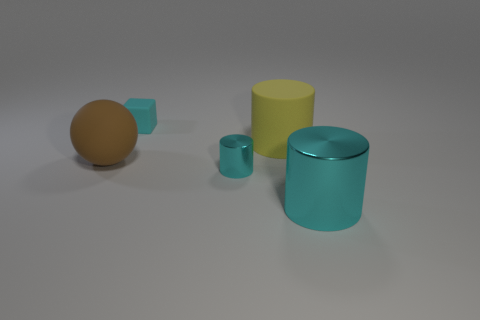Add 2 rubber blocks. How many objects exist? 7 Subtract all balls. How many objects are left? 4 Subtract all tiny yellow matte blocks. Subtract all small cylinders. How many objects are left? 4 Add 5 small cyan cylinders. How many small cyan cylinders are left? 6 Add 1 big matte balls. How many big matte balls exist? 2 Subtract 0 red cylinders. How many objects are left? 5 